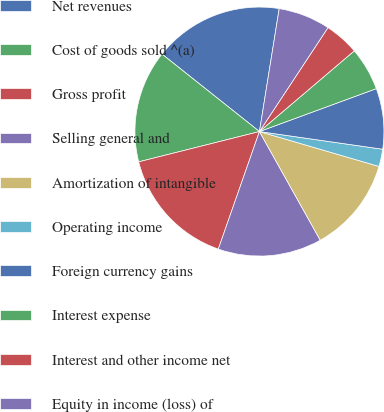Convert chart to OTSL. <chart><loc_0><loc_0><loc_500><loc_500><pie_chart><fcel>Net revenues<fcel>Cost of goods sold ^(a)<fcel>Gross profit<fcel>Selling general and<fcel>Amortization of intangible<fcel>Operating income<fcel>Foreign currency gains<fcel>Interest expense<fcel>Interest and other income net<fcel>Equity in income (loss) of<nl><fcel>16.85%<fcel>14.6%<fcel>15.73%<fcel>13.48%<fcel>12.36%<fcel>2.25%<fcel>7.87%<fcel>5.62%<fcel>4.5%<fcel>6.74%<nl></chart> 